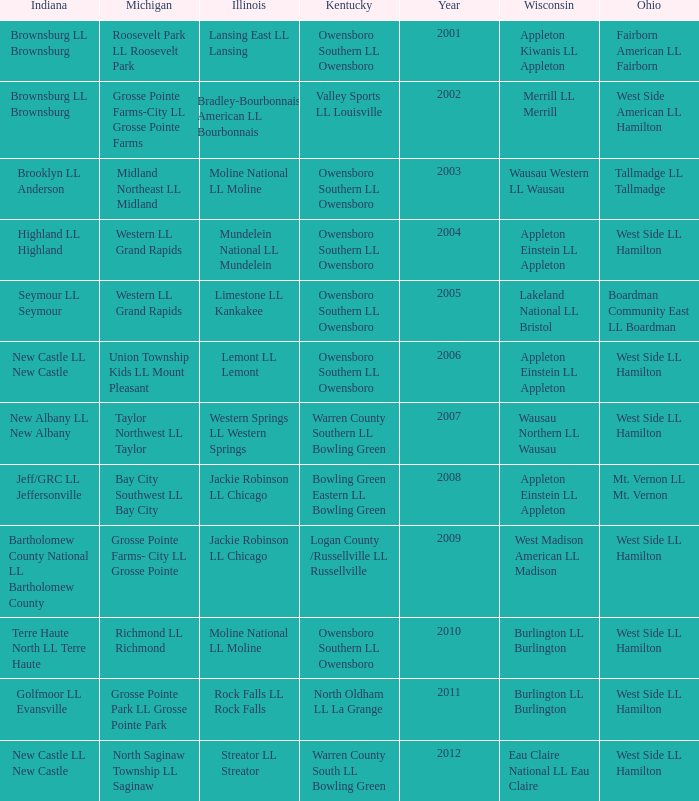What was the little league team from Michigan when the little league team from Indiana was Terre Haute North LL Terre Haute?  Richmond LL Richmond. 